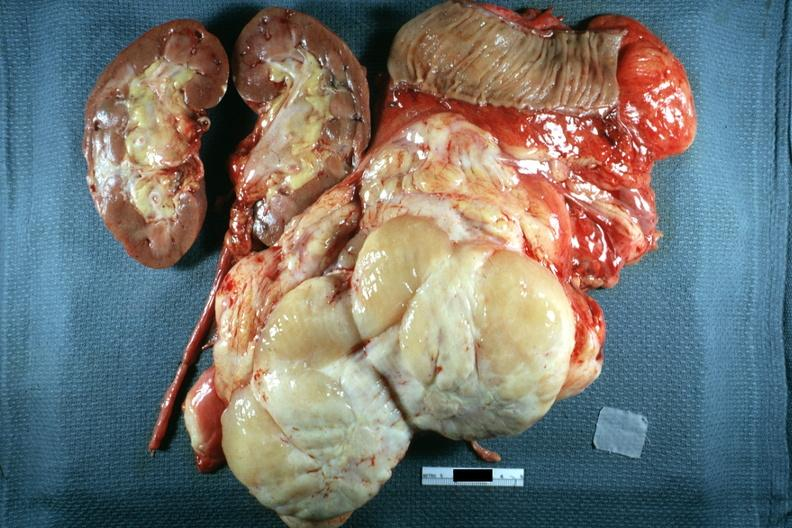s slices of liver and spleen typical tuberculous exudate is present on capsule of liver and spleen present?
Answer the question using a single word or phrase. No 